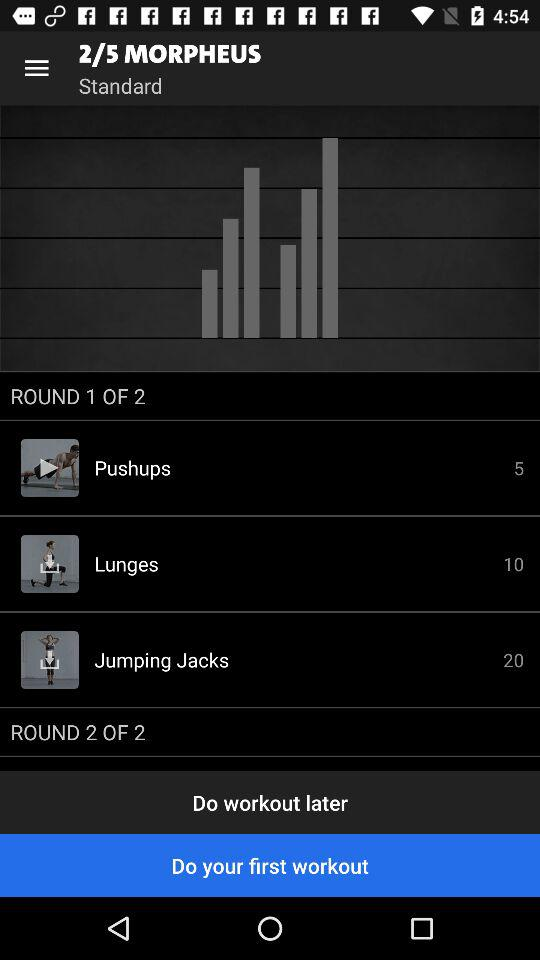How many lunges are there to do? There are 10 lunges to do. 